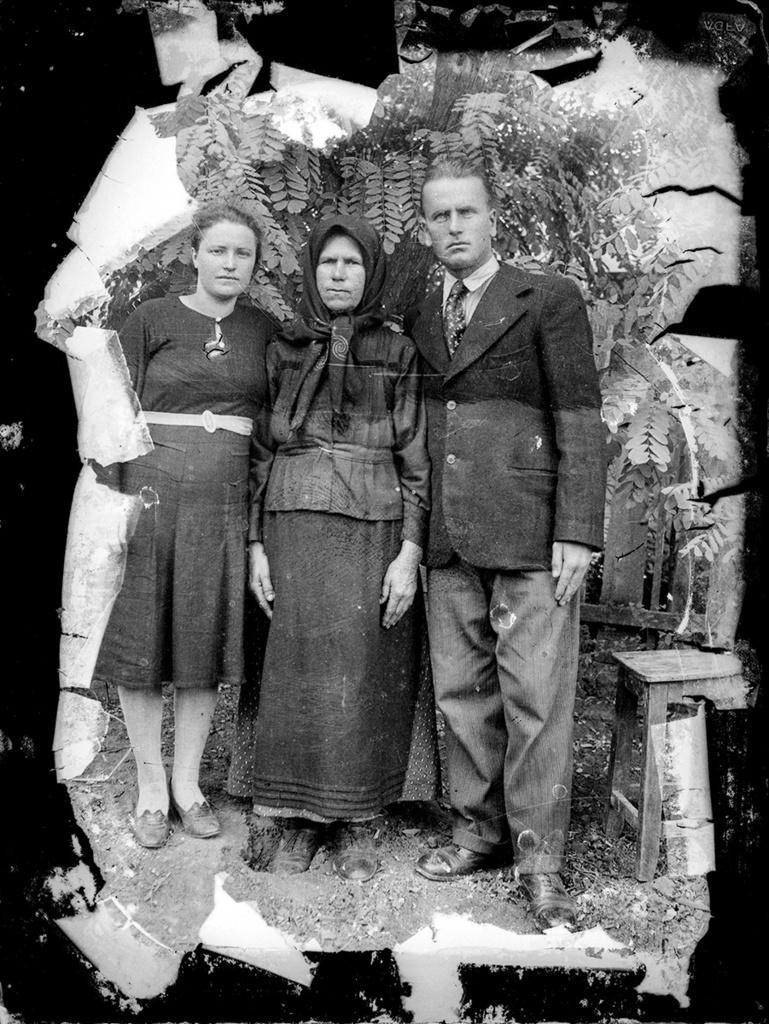Can you describe this image briefly? This is a black and white image. In the image there is a photograph. In that photograph there are three people standing. Behind them there are leaves. On the right side of the image beside the man there is a stool. 